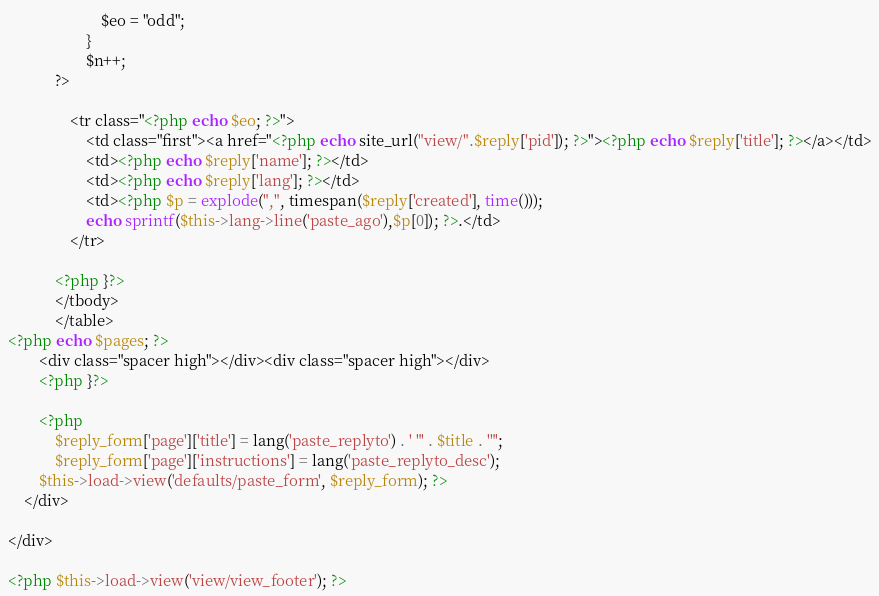Convert code to text. <code><loc_0><loc_0><loc_500><loc_500><_PHP_>						$eo = "odd";
					}
					$n++;
			?>
				
				<tr class="<?php echo $eo; ?>">
					<td class="first"><a href="<?php echo site_url("view/".$reply['pid']); ?>"><?php echo $reply['title']; ?></a></td>
					<td><?php echo $reply['name']; ?></td>
					<td><?php echo $reply['lang']; ?></td>
					<td><?php $p = explode(",", timespan($reply['created'], time()));
					echo sprintf($this->lang->line('paste_ago'),$p[0]); ?>.</td>
				</tr>
		
			<?php }?>
			</tbody>
			</table>
<?php echo $pages; ?>
		<div class="spacer high"></div><div class="spacer high"></div>
		<?php }?>
		
		<?php 
			$reply_form['page']['title'] = lang('paste_replyto') . ' "' . $title . '"';
			$reply_form['page']['instructions'] = lang('paste_replyto_desc');
		$this->load->view('defaults/paste_form', $reply_form); ?>
	</div>

</div>

<?php $this->load->view('view/view_footer'); ?>
</code> 